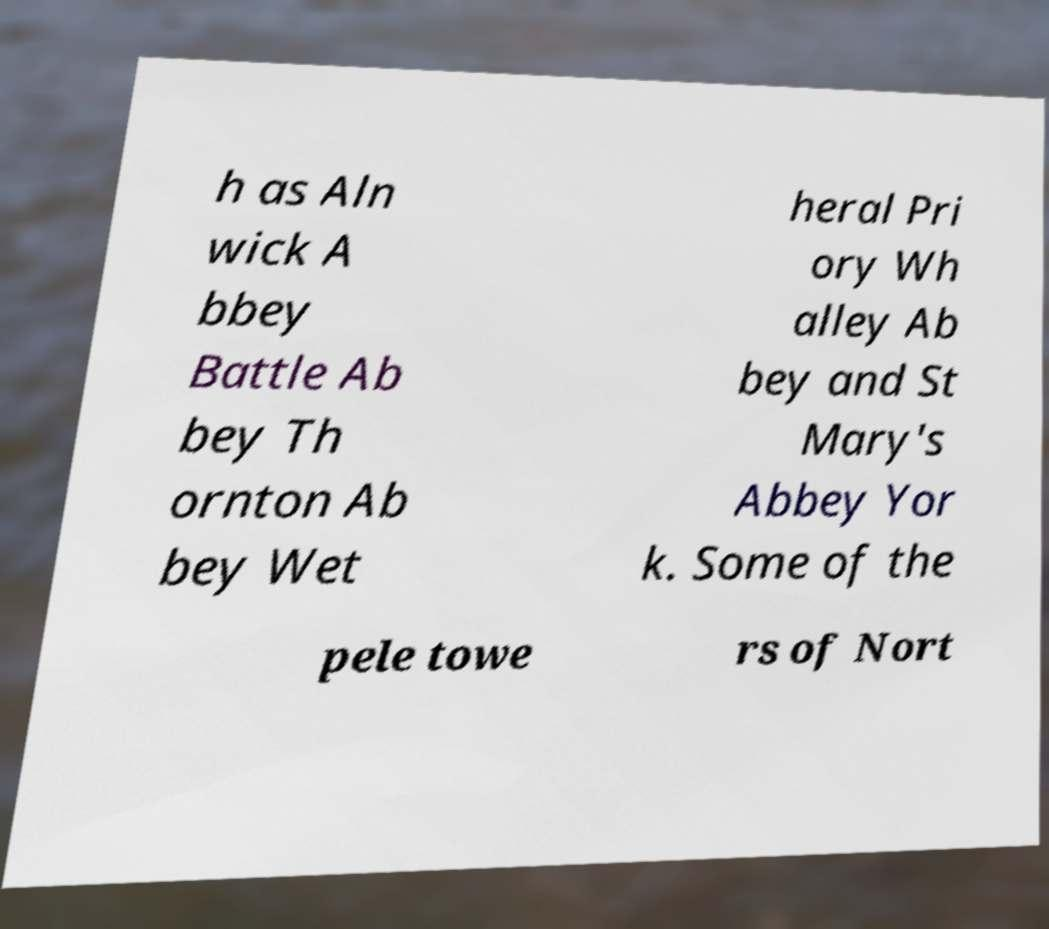Please identify and transcribe the text found in this image. h as Aln wick A bbey Battle Ab bey Th ornton Ab bey Wet heral Pri ory Wh alley Ab bey and St Mary's Abbey Yor k. Some of the pele towe rs of Nort 